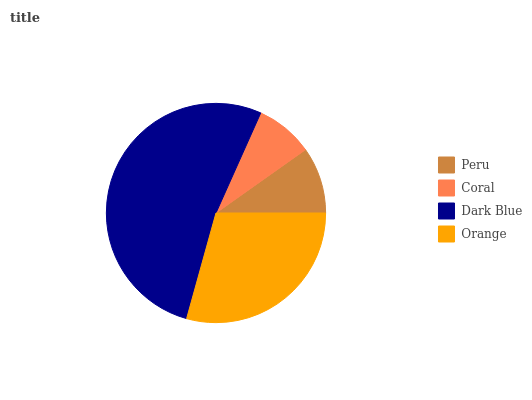Is Coral the minimum?
Answer yes or no. Yes. Is Dark Blue the maximum?
Answer yes or no. Yes. Is Dark Blue the minimum?
Answer yes or no. No. Is Coral the maximum?
Answer yes or no. No. Is Dark Blue greater than Coral?
Answer yes or no. Yes. Is Coral less than Dark Blue?
Answer yes or no. Yes. Is Coral greater than Dark Blue?
Answer yes or no. No. Is Dark Blue less than Coral?
Answer yes or no. No. Is Orange the high median?
Answer yes or no. Yes. Is Peru the low median?
Answer yes or no. Yes. Is Peru the high median?
Answer yes or no. No. Is Coral the low median?
Answer yes or no. No. 